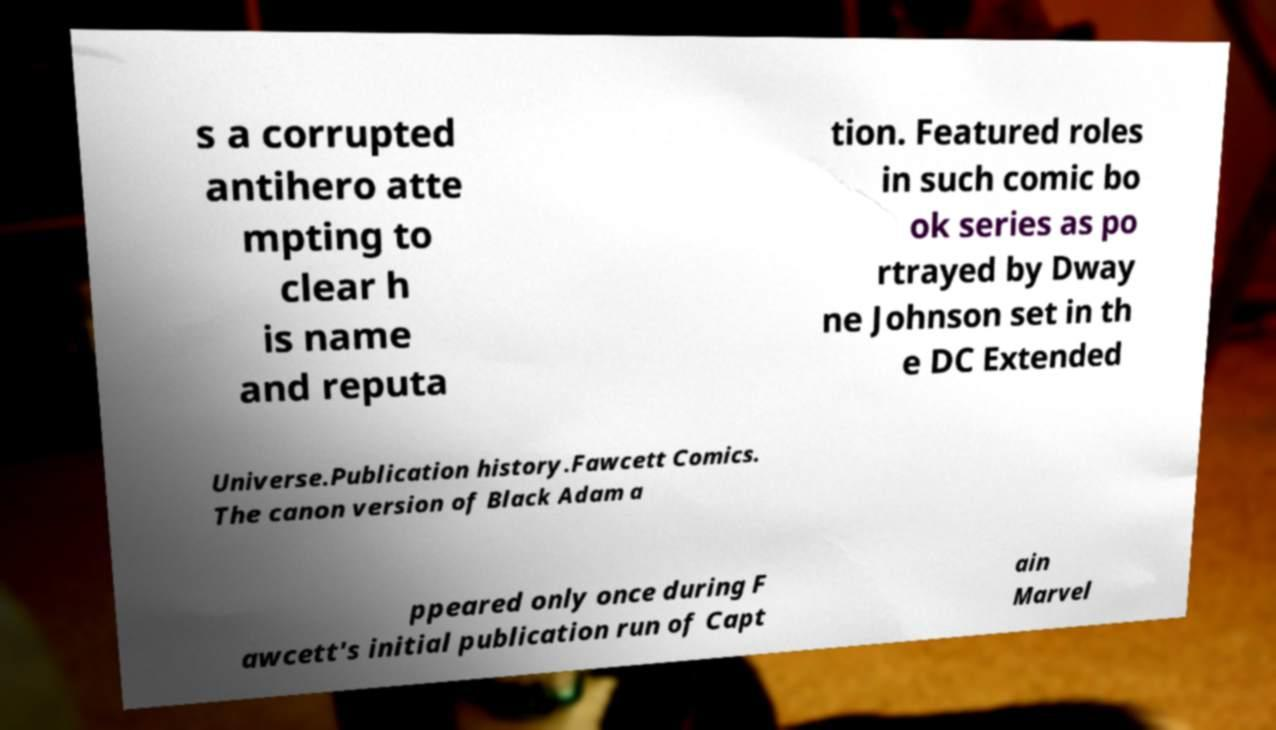Can you accurately transcribe the text from the provided image for me? s a corrupted antihero atte mpting to clear h is name and reputa tion. Featured roles in such comic bo ok series as po rtrayed by Dway ne Johnson set in th e DC Extended Universe.Publication history.Fawcett Comics. The canon version of Black Adam a ppeared only once during F awcett's initial publication run of Capt ain Marvel 